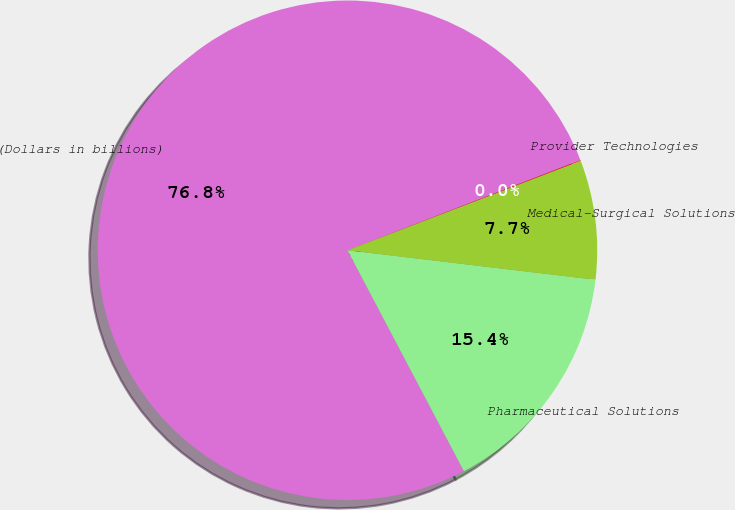Convert chart to OTSL. <chart><loc_0><loc_0><loc_500><loc_500><pie_chart><fcel>(Dollars in billions)<fcel>Pharmaceutical Solutions<fcel>Medical-Surgical Solutions<fcel>Provider Technologies<nl><fcel>76.84%<fcel>15.4%<fcel>7.72%<fcel>0.04%<nl></chart> 